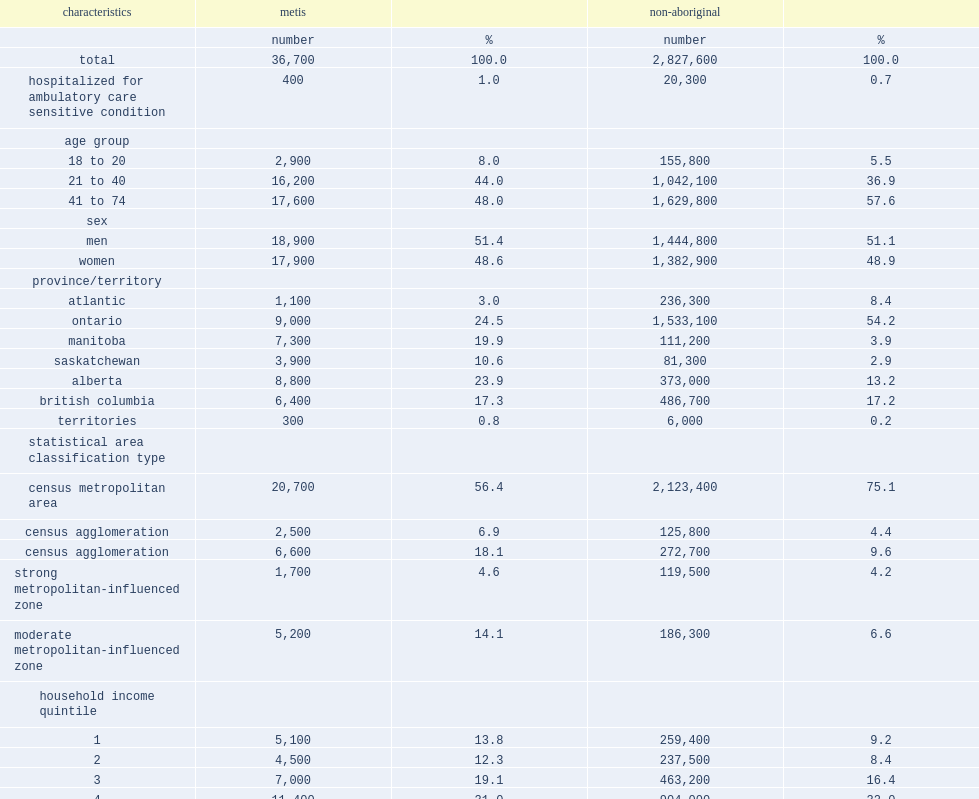How many census respondents did the cohort comprise? 2864300. How many census respondents were metis among the cohort? 36700.0. 